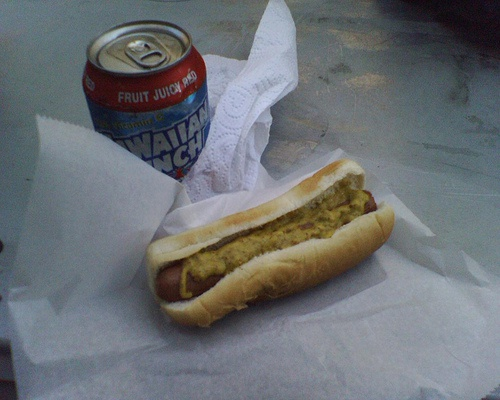Describe the objects in this image and their specific colors. I can see a hot dog in gray, olive, tan, maroon, and darkgray tones in this image. 